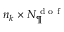<formula> <loc_0><loc_0><loc_500><loc_500>n _ { k } \times N _ { \P } ^ { d o f }</formula> 